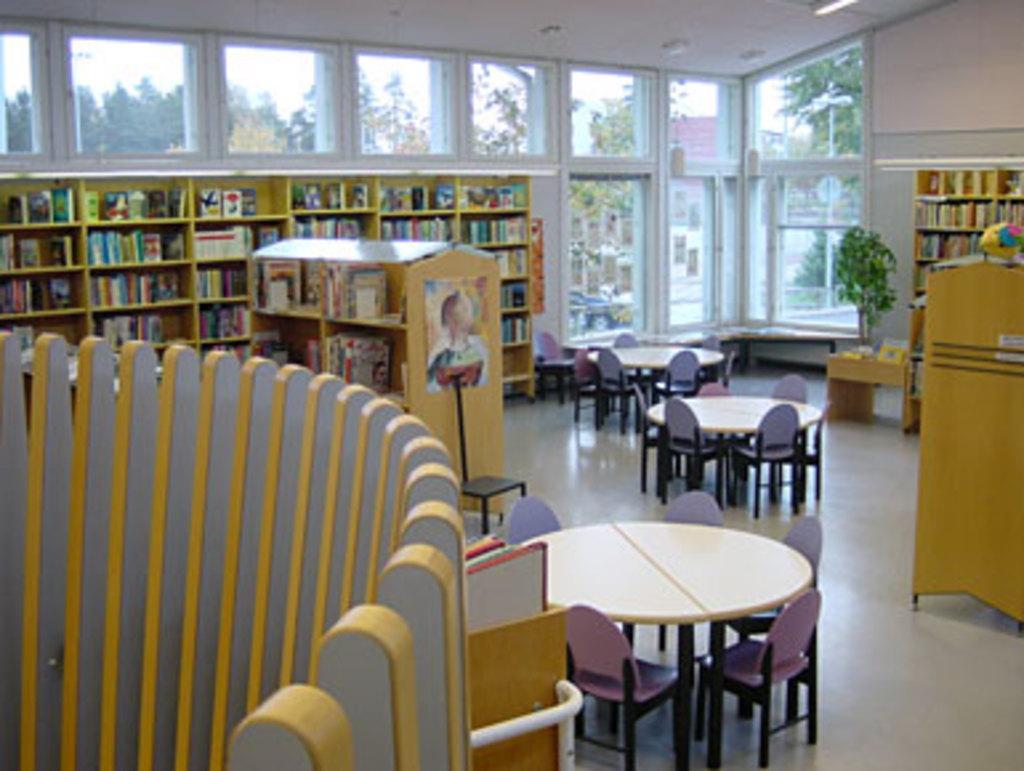Can you describe this image briefly? In this image I can see many chairs and the tables. To the left I can see the wooden objects. To the right I can see the plant and the books in the wooden rack. In the background I can see few more books in the wooden racks. Through the glass I can see many trees, house, pole and the sky. 